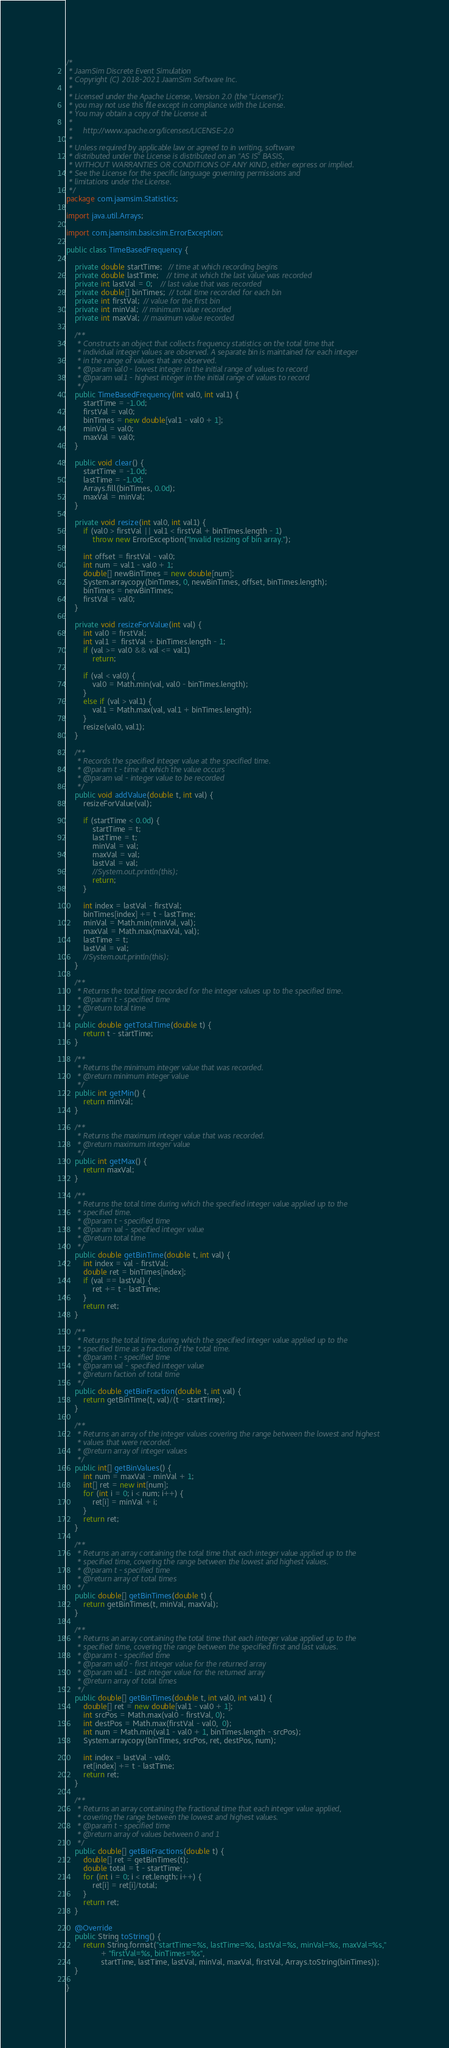Convert code to text. <code><loc_0><loc_0><loc_500><loc_500><_Java_>/*
 * JaamSim Discrete Event Simulation
 * Copyright (C) 2018-2021 JaamSim Software Inc.
 *
 * Licensed under the Apache License, Version 2.0 (the "License");
 * you may not use this file except in compliance with the License.
 * You may obtain a copy of the License at
 *
 *     http://www.apache.org/licenses/LICENSE-2.0
 *
 * Unless required by applicable law or agreed to in writing, software
 * distributed under the License is distributed on an "AS IS" BASIS,
 * WITHOUT WARRANTIES OR CONDITIONS OF ANY KIND, either express or implied.
 * See the License for the specific language governing permissions and
 * limitations under the License.
 */
package com.jaamsim.Statistics;

import java.util.Arrays;

import com.jaamsim.basicsim.ErrorException;

public class TimeBasedFrequency {

	private double startTime;   // time at which recording begins
	private double lastTime;    // time at which the last value was recorded
	private int lastVal = 0;    // last value that was recorded
	private double[] binTimes;  // total time recorded for each bin
	private int firstVal;  // value for the first bin
	private int minVal;  // minimum value recorded
	private int maxVal;  // maximum value recorded

	/**
	 * Constructs an object that collects frequency statistics on the total time that
	 * individual integer values are observed. A separate bin is maintained for each integer
	 * in the range of values that are observed.
	 * @param val0 - lowest integer in the initial range of values to record
	 * @param val1 - highest integer in the initial range of values to record
	 */
	public TimeBasedFrequency(int val0, int val1) {
		startTime = -1.0d;
		firstVal = val0;
		binTimes = new double[val1 - val0 + 1];
		minVal = val0;
		maxVal = val0;
	}

	public void clear() {
		startTime = -1.0d;
		lastTime = -1.0d;
		Arrays.fill(binTimes, 0.0d);
		maxVal = minVal;
	}

	private void resize(int val0, int val1) {
		if (val0 > firstVal || val1 < firstVal + binTimes.length - 1)
			throw new ErrorException("Invalid resizing of bin array.");

		int offset = firstVal - val0;
		int num = val1 - val0 + 1;
		double[] newBinTimes = new double[num];
		System.arraycopy(binTimes, 0, newBinTimes, offset, binTimes.length);
		binTimes = newBinTimes;
		firstVal = val0;
	}

	private void resizeForValue(int val) {
		int val0 = firstVal;
		int val1 =  firstVal + binTimes.length - 1;
		if (val >= val0 && val <= val1)
			return;

		if (val < val0) {
			val0 = Math.min(val, val0 - binTimes.length);
		}
		else if (val > val1) {
			val1 = Math.max(val, val1 + binTimes.length);
		}
		resize(val0, val1);
	}

	/**
	 * Records the specified integer value at the specified time.
	 * @param t - time at which the value occurs
	 * @param val - integer value to be recorded
	 */
	public void addValue(double t, int val) {
		resizeForValue(val);

		if (startTime < 0.0d) {
			startTime = t;
			lastTime = t;
			minVal = val;
			maxVal = val;
			lastVal = val;
			//System.out.println(this);
			return;
		}

		int index = lastVal - firstVal;
		binTimes[index] += t - lastTime;
		minVal = Math.min(minVal, val);
		maxVal = Math.max(maxVal, val);
		lastTime = t;
		lastVal = val;
		//System.out.println(this);
	}

	/**
	 * Returns the total time recorded for the integer values up to the specified time.
	 * @param t - specified time
	 * @return total time
	 */
	public double getTotalTime(double t) {
		return t - startTime;
	}

	/**
	 * Returns the minimum integer value that was recorded.
	 * @return minimum integer value
	 */
	public int getMin() {
		return minVal;
	}

	/**
	 * Returns the maximum integer value that was recorded.
	 * @return maximum integer value
	 */
	public int getMax() {
		return maxVal;
	}

	/**
	 * Returns the total time during which the specified integer value applied up to the
	 * specified time.
	 * @param t - specified time
	 * @param val - specified integer value
	 * @return total time
	 */
	public double getBinTime(double t, int val) {
		int index = val - firstVal;
		double ret = binTimes[index];
		if (val == lastVal) {
			ret += t - lastTime;
		}
		return ret;
	}

	/**
	 * Returns the total time during which the specified integer value applied up to the
	 * specified time as a fraction of the total time.
	 * @param t - specified time
	 * @param val - specified integer value
	 * @return faction of total time
	 */
	public double getBinFraction(double t, int val) {
		return getBinTime(t, val)/(t - startTime);
	}

	/**
	 * Returns an array of the integer values covering the range between the lowest and highest
	 * values that were recorded.
	 * @return array of integer values
	 */
	public int[] getBinValues() {
		int num = maxVal - minVal + 1;
		int[] ret = new int[num];
		for (int i = 0; i < num; i++) {
			ret[i] = minVal + i;
		}
		return ret;
	}

	/**
	 * Returns an array containing the total time that each integer value applied up to the
	 * specified time, covering the range between the lowest and highest values.
	 * @param t - specified time
	 * @return array of total times
	 */
	public double[] getBinTimes(double t) {
		return getBinTimes(t, minVal, maxVal);
	}

	/**
	 * Returns an array containing the total time that each integer value applied up to the
	 * specified time, covering the range between the specified first and last values.
	 * @param t - specified time
	 * @param val0 - first integer value for the returned array
	 * @param val1 - last integer value for the returned array
	 * @return array of total times
	 */
	public double[] getBinTimes(double t, int val0, int val1) {
		double[] ret = new double[val1 - val0 + 1];
		int srcPos = Math.max(val0 - firstVal, 0);
		int destPos = Math.max(firstVal - val0,  0);
		int num = Math.min(val1 - val0 + 1, binTimes.length - srcPos);
		System.arraycopy(binTimes, srcPos, ret, destPos, num);

		int index = lastVal - val0;
		ret[index] += t - lastTime;
		return ret;
	}

	/**
	 * Returns an array containing the fractional time that each integer value applied,
	 * covering the range between the lowest and highest values.
	 * @param t - specified time
	 * @return array of values between 0 and 1
	 */
	public double[] getBinFractions(double t) {
		double[] ret = getBinTimes(t);
		double total = t - startTime;
		for (int i = 0; i < ret.length; i++) {
			ret[i] = ret[i]/total;
		}
		return ret;
	}

	@Override
	public String toString() {
		return String.format("startTime=%s, lastTime=%s, lastVal=%s, minVal=%s, maxVal=%s,"
				+ "firstVal=%s, binTimes=%s",
				startTime, lastTime, lastVal, minVal, maxVal, firstVal, Arrays.toString(binTimes));
	}

}
</code> 